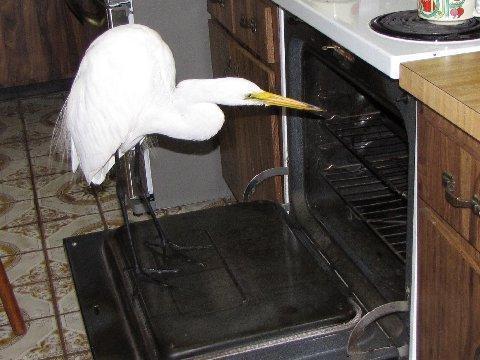Is "The bird is next to the oven." an appropriate description for the image?
Answer yes or no. Yes. 